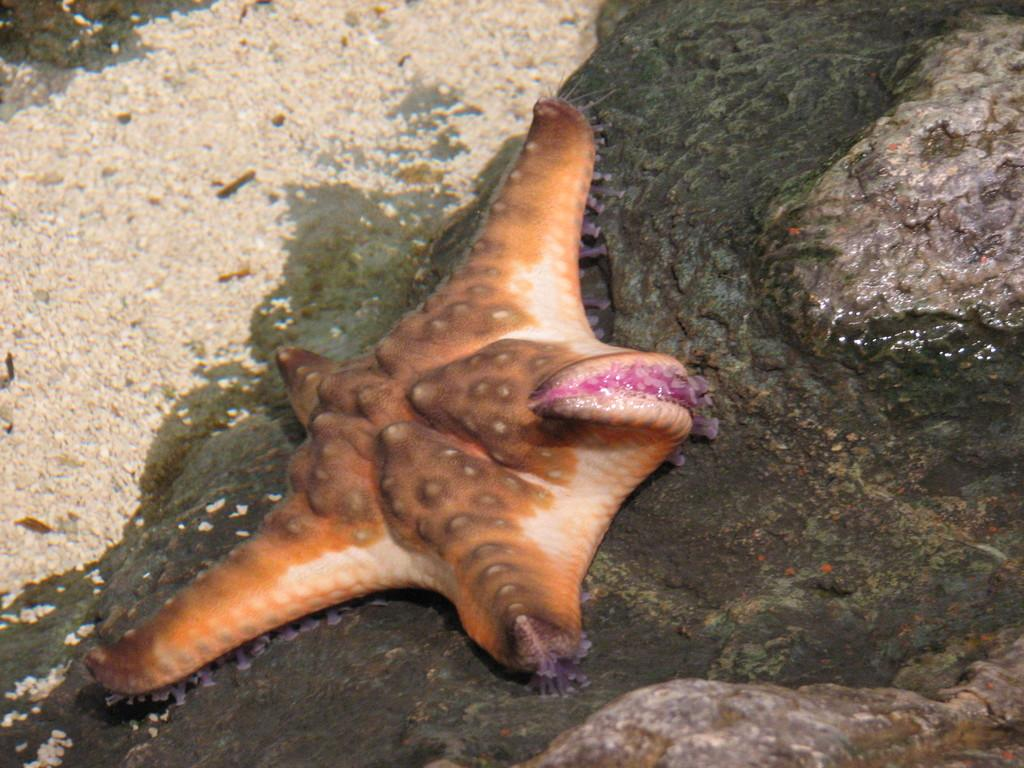What is the main subject of the image? There is a starfish in the image. Where is the starfish located? The starfish is on the ground. What colors can be seen on the starfish? The starfish has brown, cream, and pink colors. How many wings can be seen on the starfish in the image? There are no wings on the starfish in the image, as starfish do not have wings. How many frogs are present in the image? There are no frogs present in the image; the main subject is a starfish. 